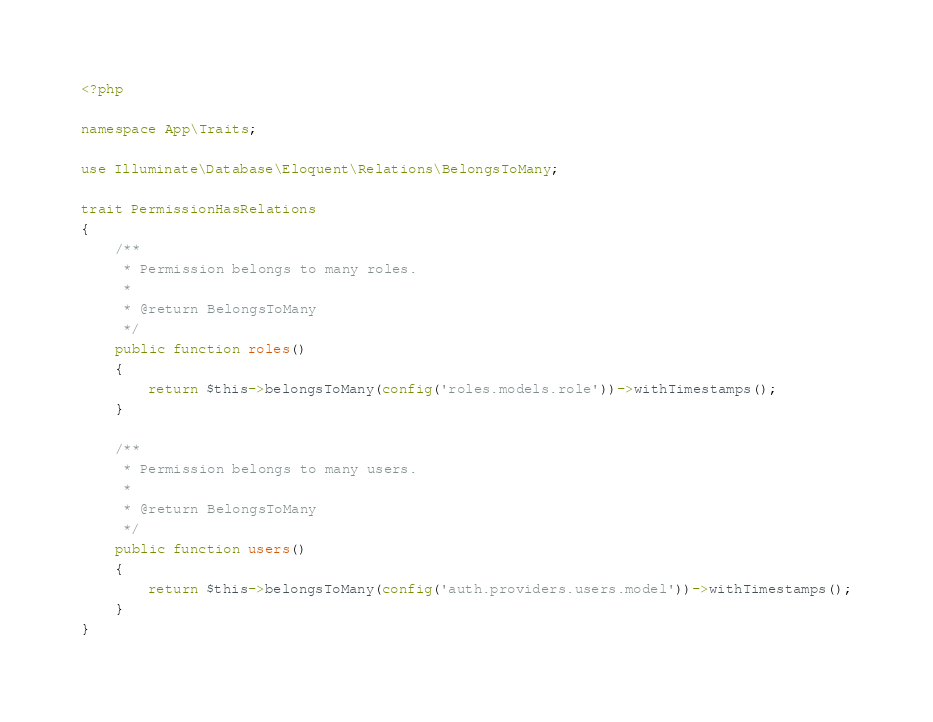Convert code to text. <code><loc_0><loc_0><loc_500><loc_500><_PHP_><?php

namespace App\Traits;

use Illuminate\Database\Eloquent\Relations\BelongsToMany;

trait PermissionHasRelations
{
    /**
     * Permission belongs to many roles.
     *
     * @return BelongsToMany
     */
    public function roles()
    {
        return $this->belongsToMany(config('roles.models.role'))->withTimestamps();
    }

    /**
     * Permission belongs to many users.
     *
     * @return BelongsToMany
     */
    public function users()
    {
        return $this->belongsToMany(config('auth.providers.users.model'))->withTimestamps();
    }
}
</code> 